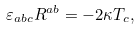<formula> <loc_0><loc_0><loc_500><loc_500>\varepsilon _ { a b c } R ^ { a b } = - { 2 \kappa } T _ { c } ,</formula> 